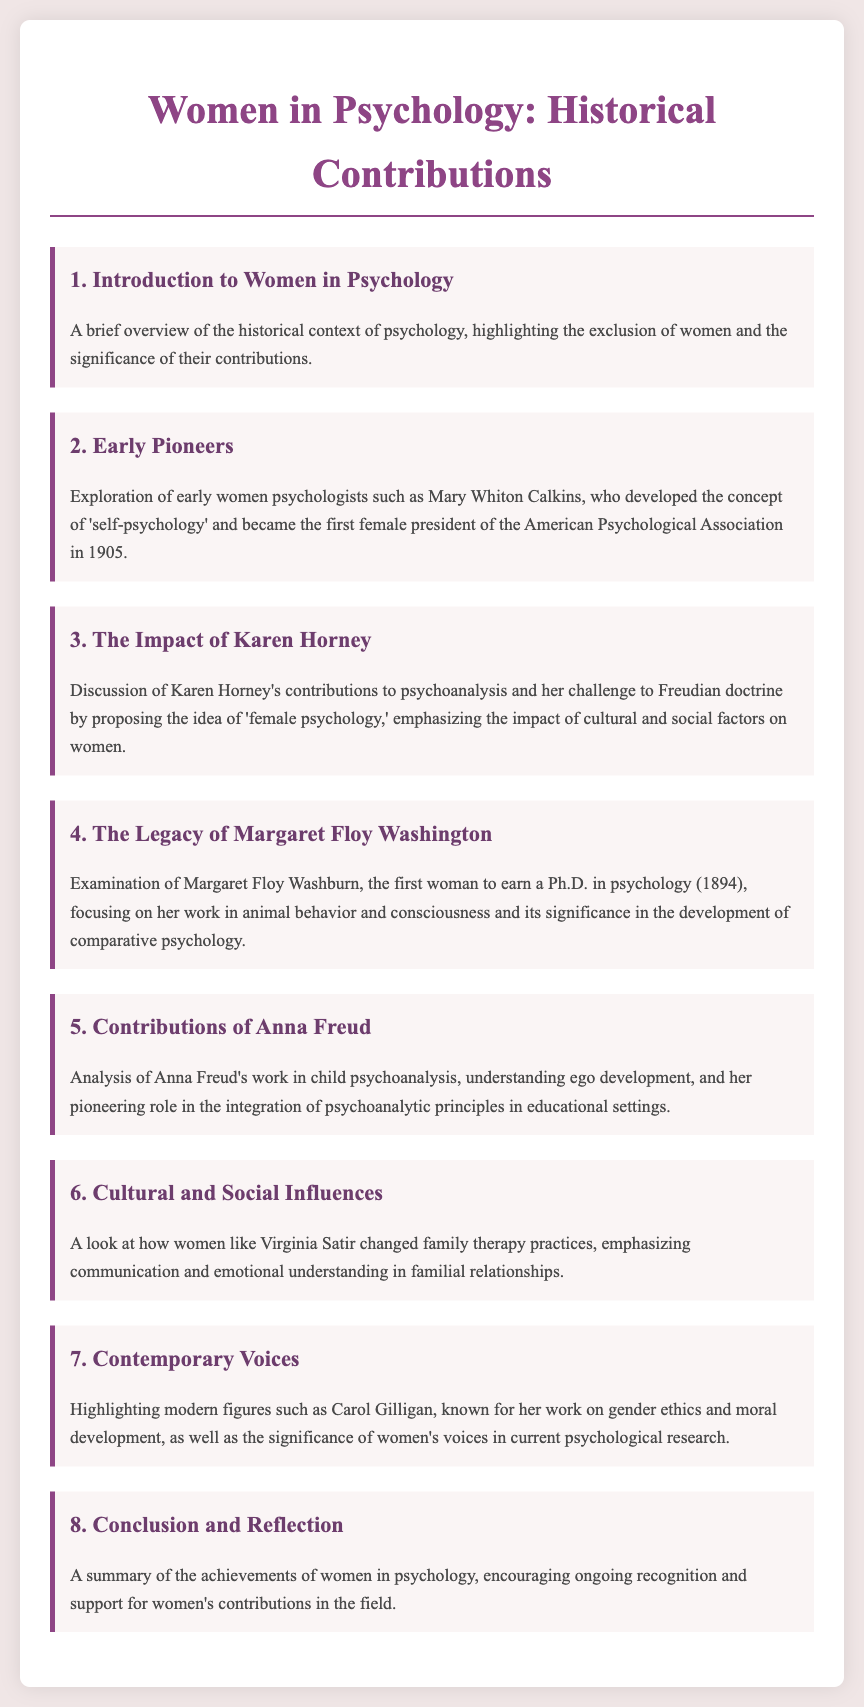What is the title of the document? The title of the document is presented in the header and indicates the focus on women in psychology and their historical contributions.
Answer: Women in Psychology: Historical Contributions Who is the first female president of the American Psychological Association? The document states that Mary Whiton Calkins became the first female president in 1905, highlighting her significance in psychology.
Answer: Mary Whiton Calkins What year did Margaret Floy Washburn earn her Ph.D. in psychology? The agenda lists the year 1894 as when Margaret Floy Washburn became the first woman to earn a Ph.D. in psychology.
Answer: 1894 What concept did Karen Horney propose? The document mentions that Karen Horney challenged Freudian doctrine and proposed the idea of 'female psychology.'
Answer: Female psychology Which psychologist is known for their work on gender ethics? The agenda highlights Carol Gilligan as a modern figure known for her contributions to gender ethics and moral development.
Answer: Carol Gilligan How did Virginia Satir influence family therapy? According to the document, Virginia Satir changed family therapy practices by emphasizing communication and emotional understanding.
Answer: Communication and emotional understanding What is the focus of the final agenda item? The last item encourages ongoing recognition and support for women's contributions in psychology, summarizing their achievements.
Answer: Recognition and support for women's contributions What is the primary theme of the document? The overarching theme is the exploration and recognition of women's historical contributions to psychology.
Answer: Women's historical contributions to psychology 